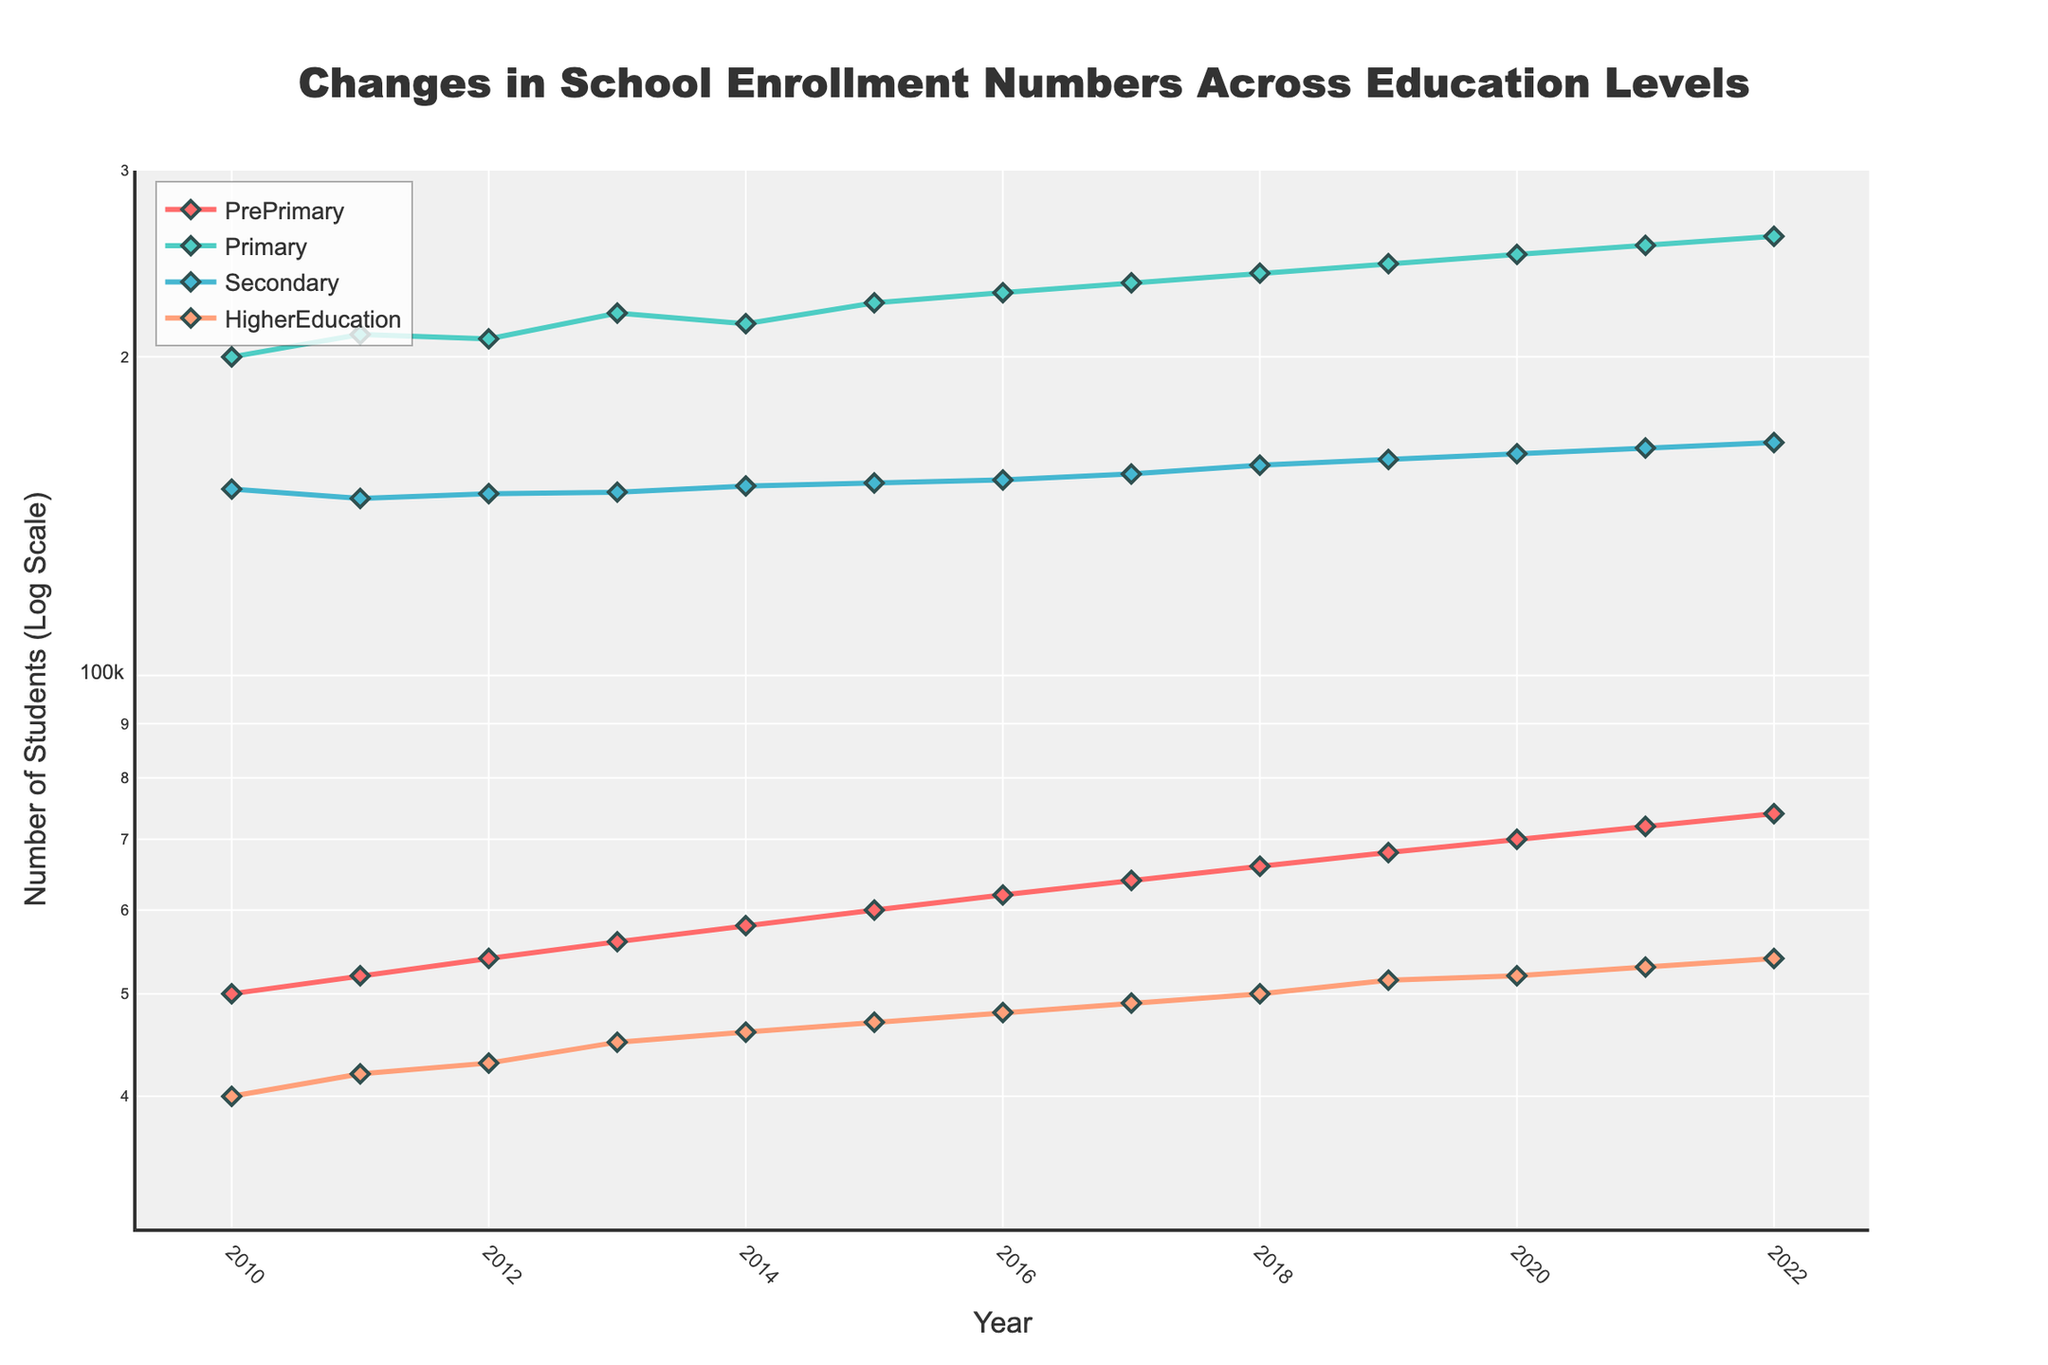what's the title of the figure? The title is placed at the top center of the figure and reads as "Changes in School Enrollment Numbers Across Education Levels".
Answer: Changes in School Enrollment Numbers Across Education Levels How many education levels are displayed in the figure? There are four lines representing four education levels in the figure: PrePrimary, Primary, Secondary, and HigherEducation.
Answer: Four Which education level had the highest enrollment in 2015? The Primary education level had the highest line and mark on the plot in 2015.
Answer: Primary What's the trend of HigherEducation enrollment from 2010 to 2022? The line representing HigherEducation rises steadily over the years from 40,000 in 2010 to 54,000 in 2022.
Answer: Steady increase Compare the enrollment numbers in PrePrimary and Secondary education levels for the year 2020. The PrePrimary enrollment is 70,000 and the Secondary enrollment is 162,000 for the year 2020, given by their respective positions on the y-axis.
Answer: PrePrimary: 70,000, Secondary: 162,000 Which education level shows the most consistent growth over the years? By analyzing the slopes of the lines, Primary education shows a very consistent steady growth compared to other levels.
Answer: Primary In which years did the Primary education level experience a drop in enrollment? There was no drop; Primary education level's line shows a continuous increase each year from 2010 to 2022.
Answer: None What was the total enrollment number across all education levels in the year 2017? Adding up the enrollments: 64,000 (PrePrimary) + 235,000 (Primary) + 155,000 (Secondary) + 49,000 (HigherEducation) = 503,000.
Answer: 503,000 Which year shows the first significant jump in PrePrimary enrollment? The first notably significant jump in the slope of the PrePrimary line occurs between 2010 to 2011, going from 50,000 to 52,000.
Answer: 2011 What is the log scale range used for the y-axis? The y-axis ranges from approximately 30,000 (log10(30000) is about 4.477) to 300,000 (log10(300000) is about 5.477) in the log scale.
Answer: From 30,000 to 300,000 